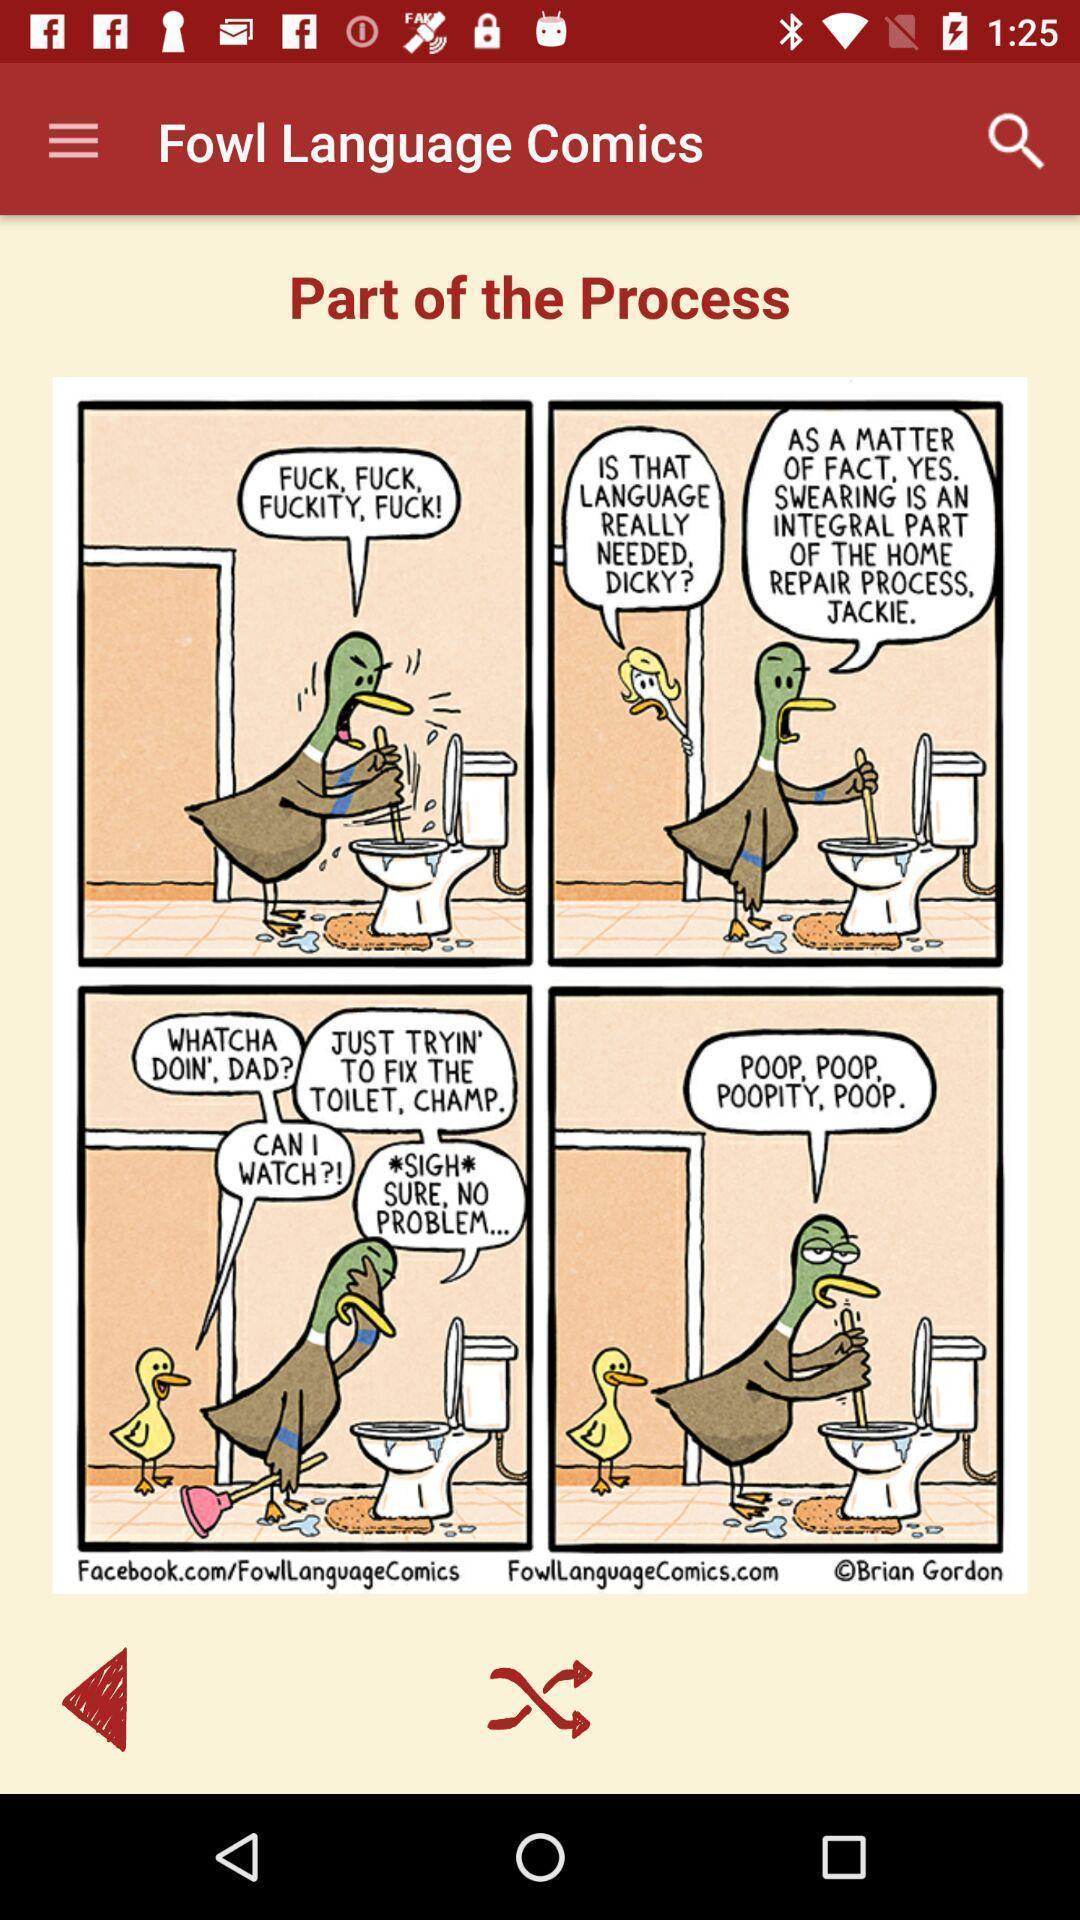What can you discern from this picture? Screen displaying the comics page. 